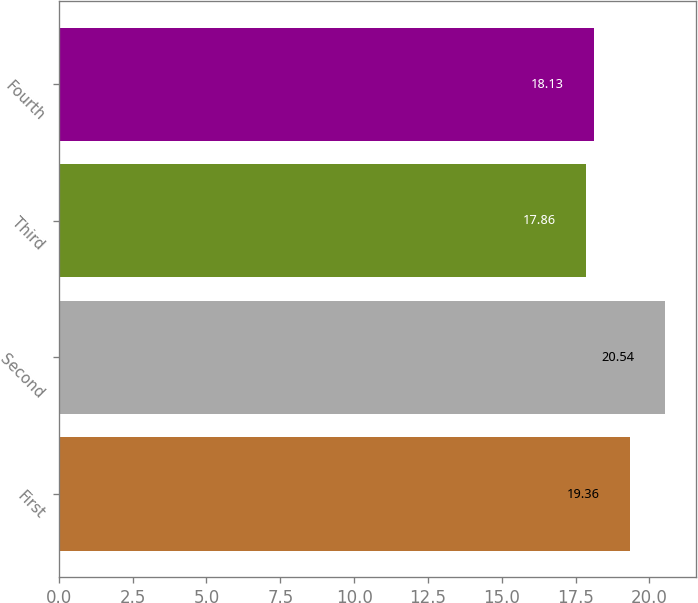<chart> <loc_0><loc_0><loc_500><loc_500><bar_chart><fcel>First<fcel>Second<fcel>Third<fcel>Fourth<nl><fcel>19.36<fcel>20.54<fcel>17.86<fcel>18.13<nl></chart> 